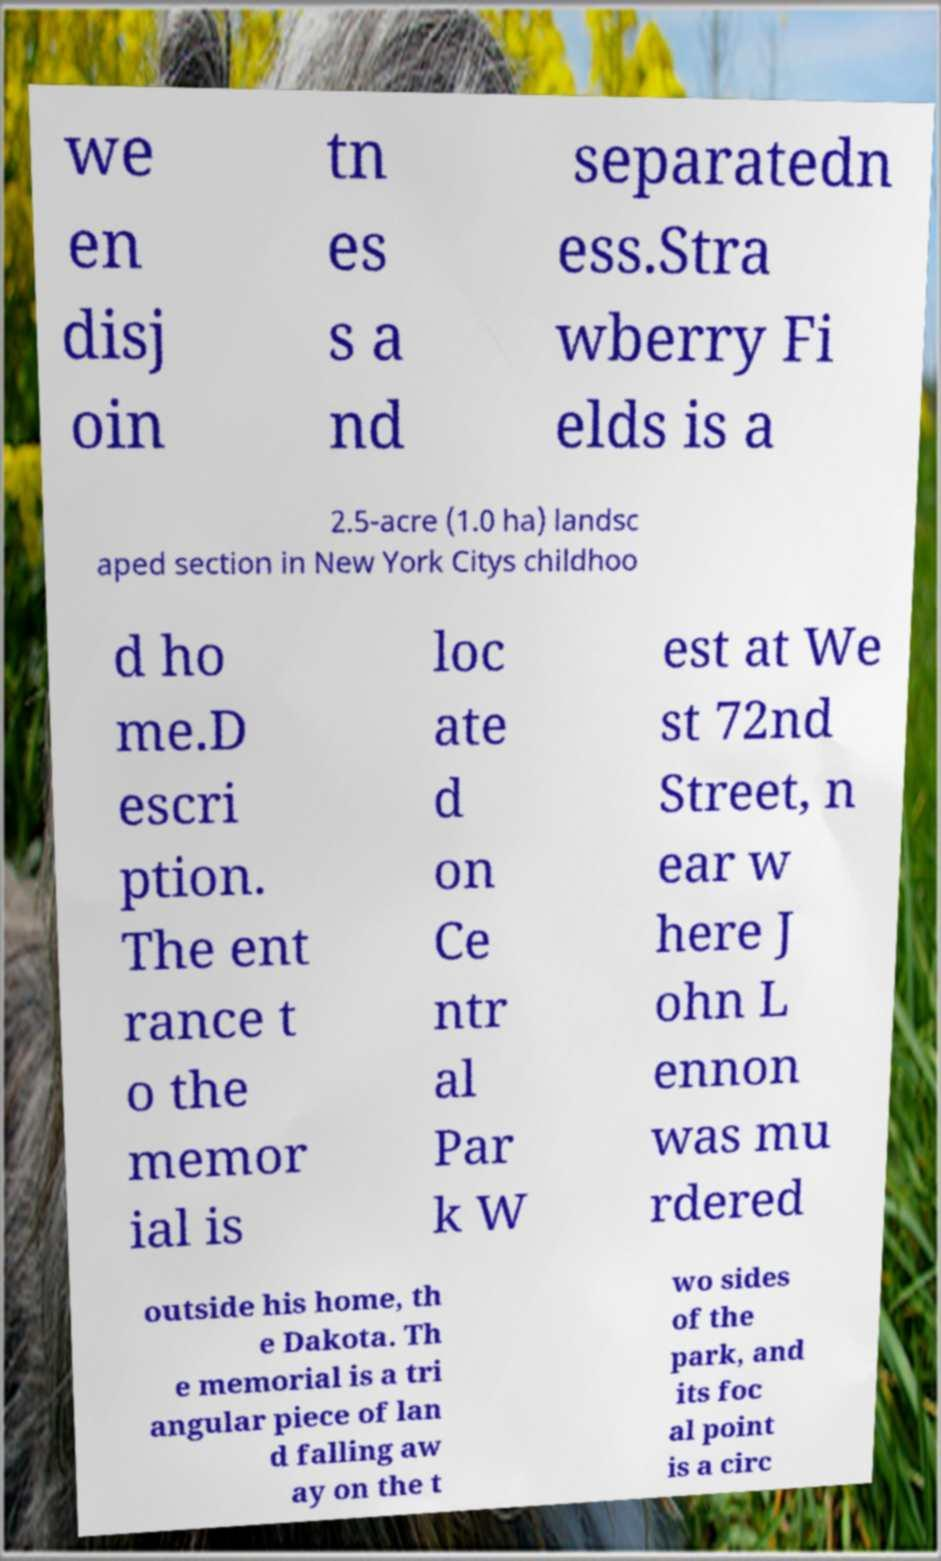I need the written content from this picture converted into text. Can you do that? we en disj oin tn es s a nd separatedn ess.Stra wberry Fi elds is a 2.5-acre (1.0 ha) landsc aped section in New York Citys childhoo d ho me.D escri ption. The ent rance t o the memor ial is loc ate d on Ce ntr al Par k W est at We st 72nd Street, n ear w here J ohn L ennon was mu rdered outside his home, th e Dakota. Th e memorial is a tri angular piece of lan d falling aw ay on the t wo sides of the park, and its foc al point is a circ 